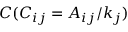<formula> <loc_0><loc_0><loc_500><loc_500>C ( C _ { i j } = A _ { i j } / k _ { j } )</formula> 